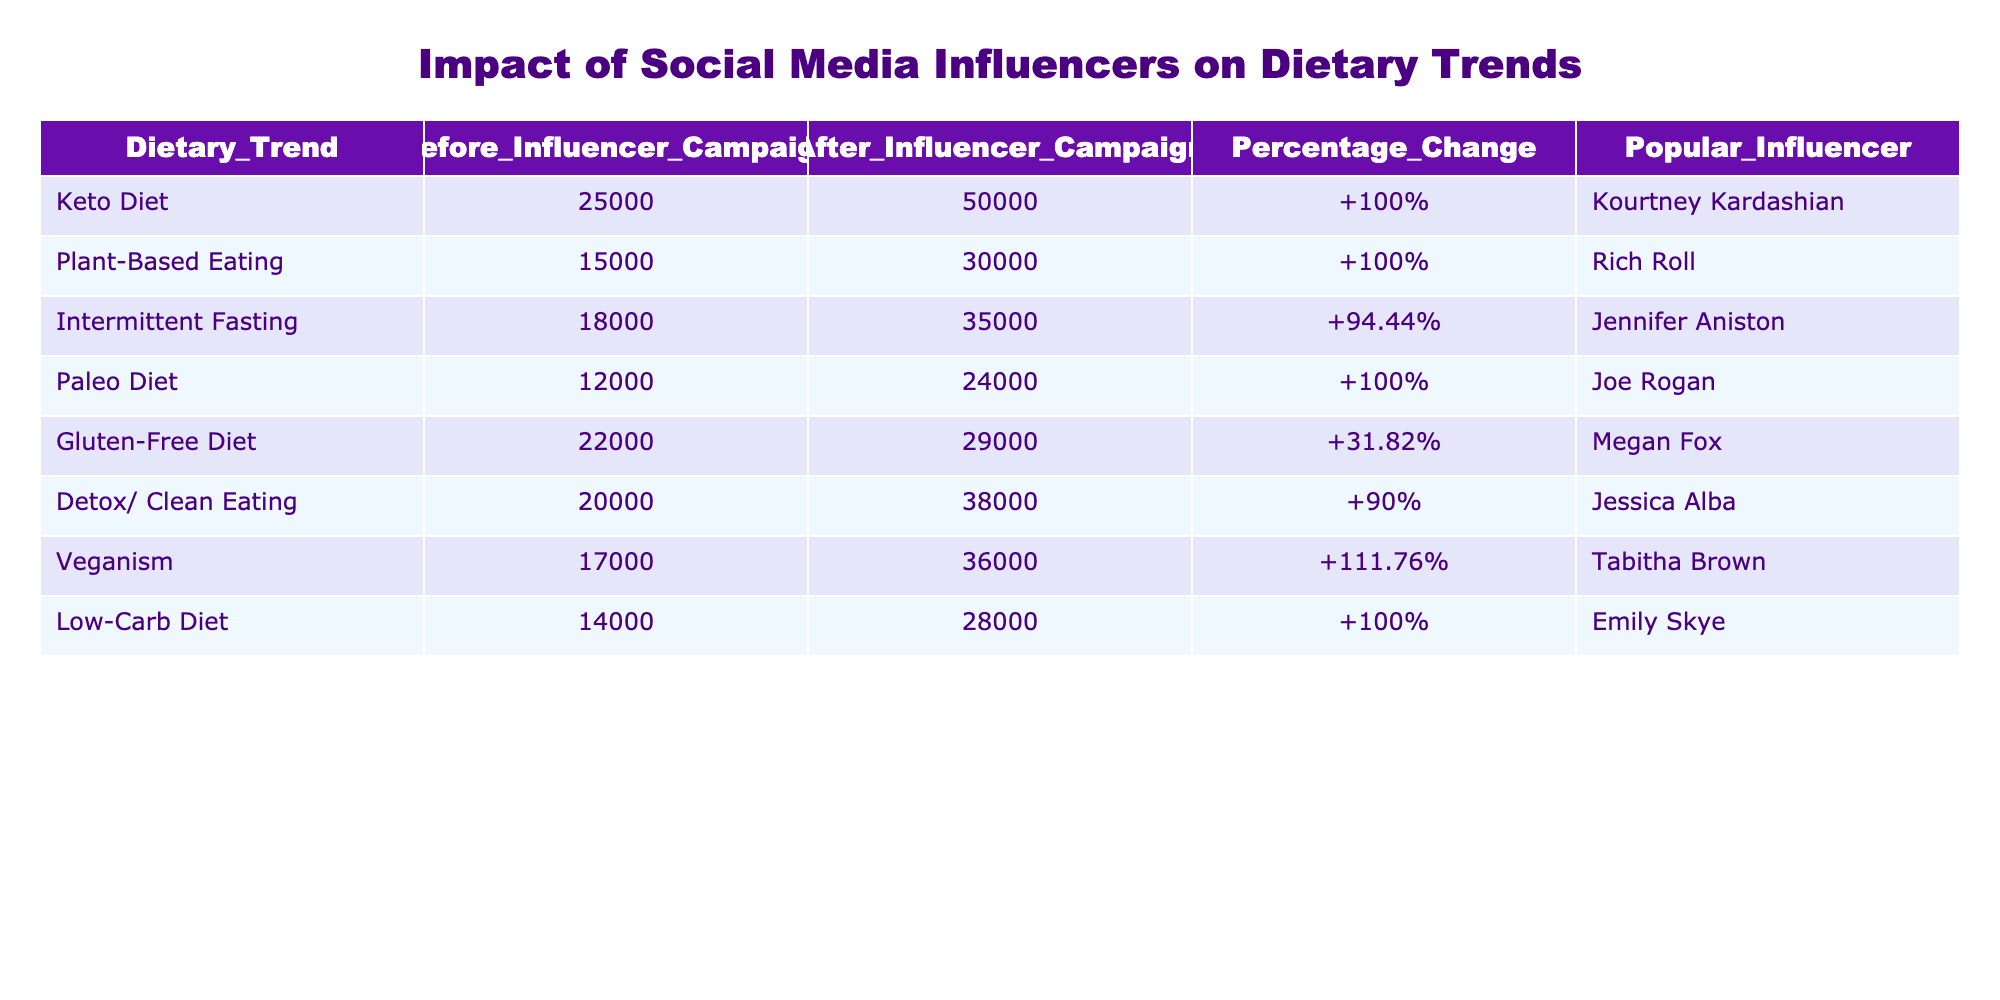What is the highest percentage change in dietary trends after influencer campaigns? Looking at the table, the percentage change for Veganism is 111.76%, which is the highest compared to other dietary trends.
Answer: 111.76% Who was the popular influencer for the Paleo Diet? The table shows that the popular influencer for the Paleo Diet is Joe Rogan.
Answer: Joe Rogan How many people followed Plant-Based Eating before the influencer campaign? The table indicates that 15,000 people followed Plant-Based Eating before the influencer campaign.
Answer: 15,000 What is the average number of followers for all dietary trends after influencer campaigns? To find the average, sum the after campaign followers (50000 + 30000 + 35000 + 24000 + 29000 + 38000 + 36000 + 28000) = 286000, then divide by the total number of dietary trends (8): 286000/8 = 35750.
Answer: 35750 Is the percentage change for the Gluten-Free Diet greater than 30%? The percentage change for the Gluten-Free Diet is 31.82%, which is greater than 30%, confirming the statement as true.
Answer: Yes Which dietary trend had the smallest increase after the influencer campaign? By comparing the percentage changes, the Gluten-Free Diet had the smallest increase at 31.82%.
Answer: Gluten-Free Diet If you combine the number of followers for the Keto Diet and the Intermittent Fasting after the campaign, what is the total? The number of followers after the campaign for Keto Diet is 50000 and for Intermittent Fasting is 35000. Adding them together gives 50000 + 35000 = 85000.
Answer: 85000 How many more people followed Detox/Clean Eating after the campaign compared to before? The difference in followers for Detox/Clean Eating is calculated by subtracting the before numbers (38000 - 20000) = 18000.
Answer: 18000 Did the Influencer campaigns double the followers for both Keto Diet and Veganism? The before and after followers show that Keto Diet increased from 25000 to 50000 (double) and Veganism from 17000 to 36000 (not double). Thus, the statement is partially true.
Answer: No 